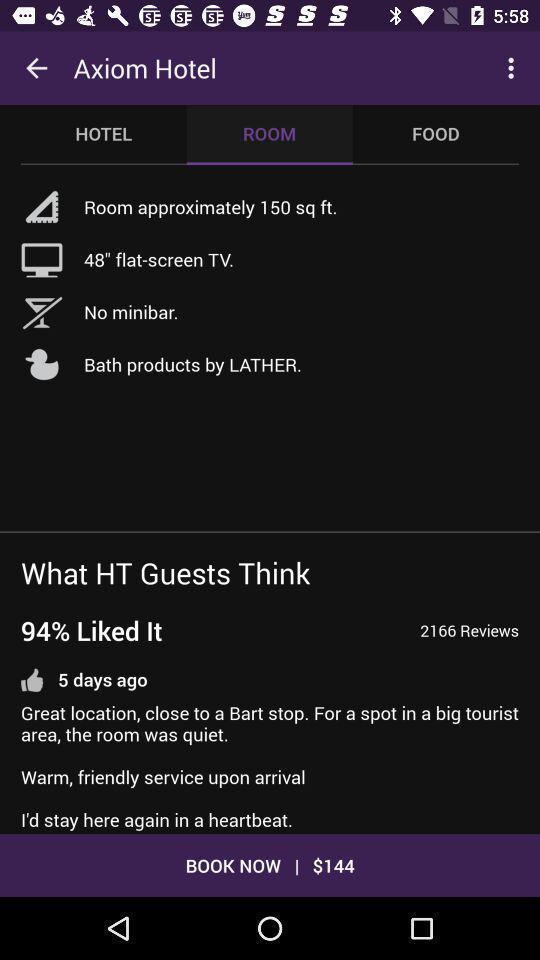Explain the elements present in this screenshot. Screen displaying the room information in hotel to book. 